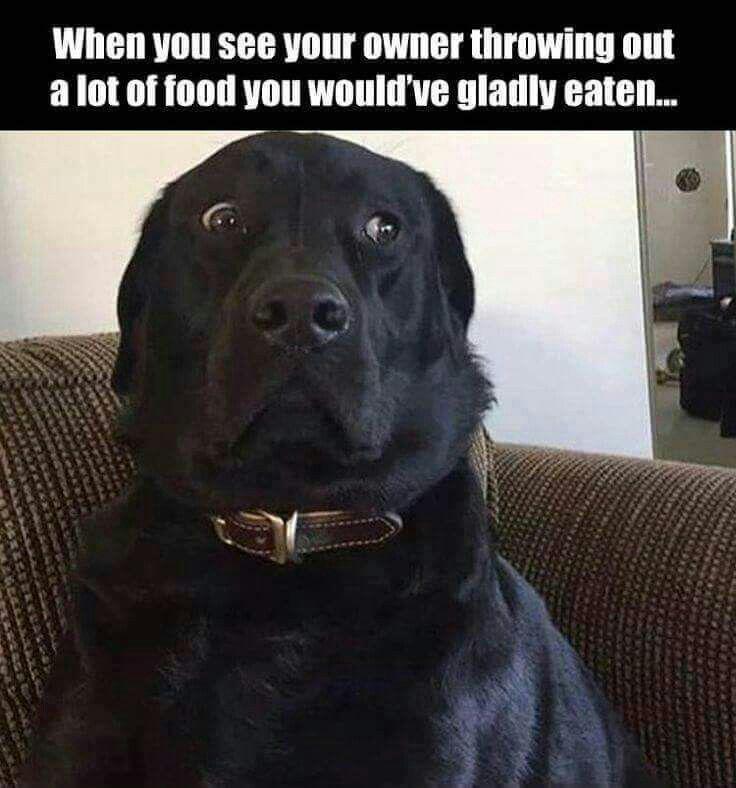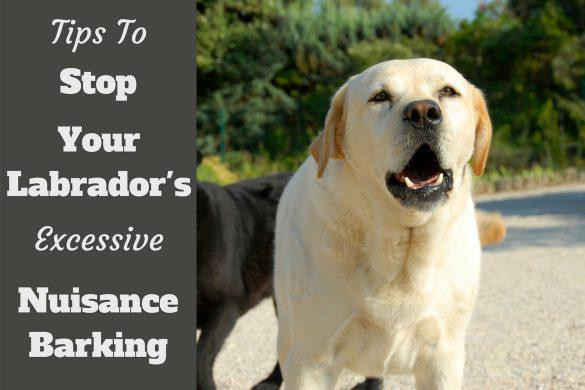The first image is the image on the left, the second image is the image on the right. Analyze the images presented: Is the assertion "There are two dogs in the image on the left." valid? Answer yes or no. No. 